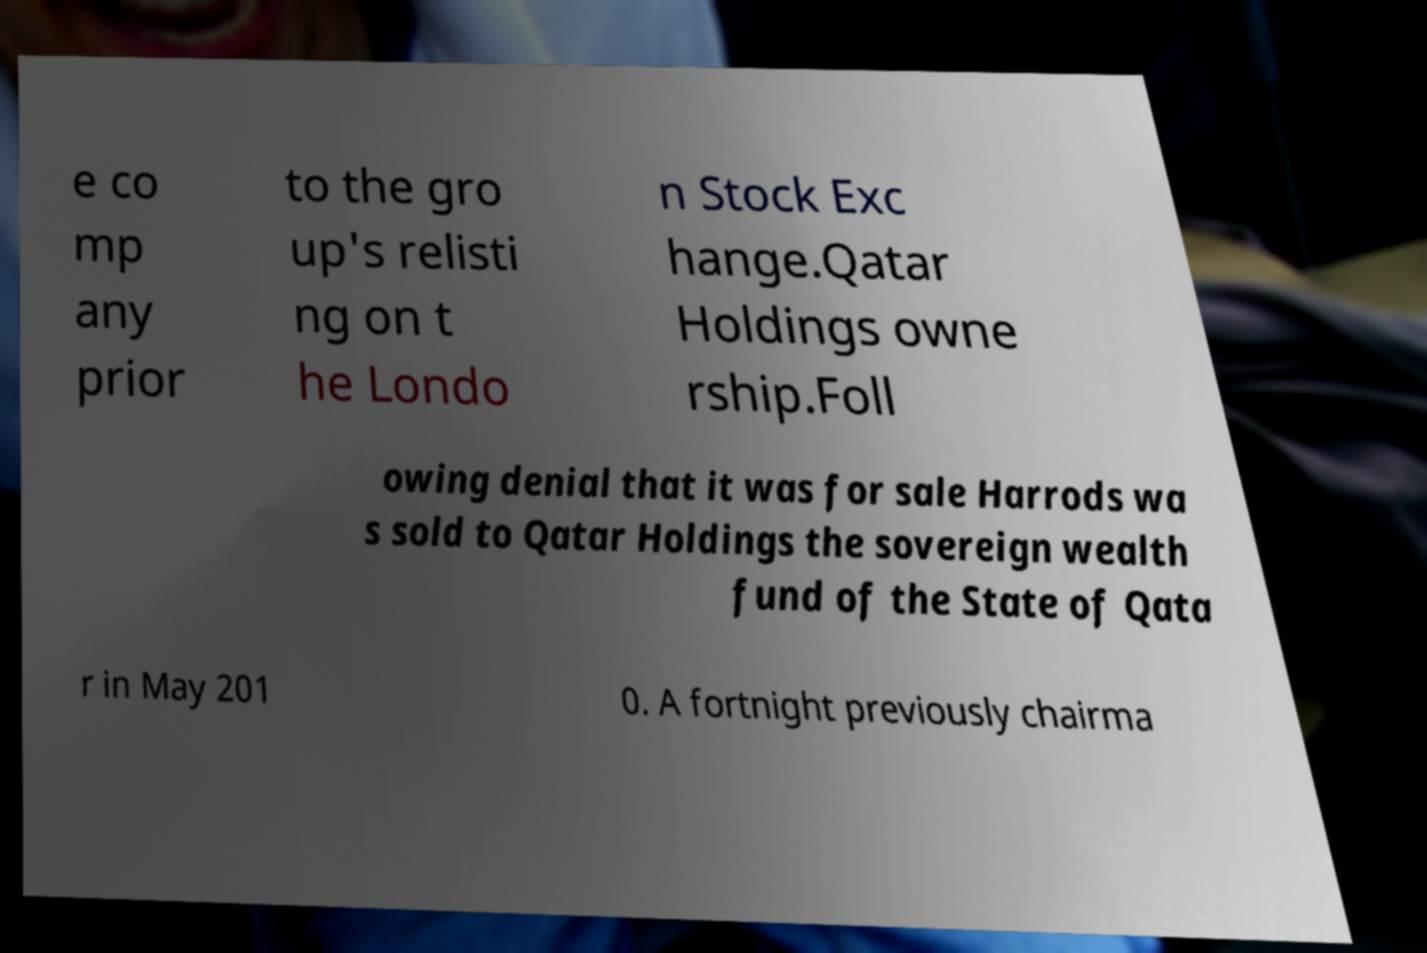What messages or text are displayed in this image? I need them in a readable, typed format. e co mp any prior to the gro up's relisti ng on t he Londo n Stock Exc hange.Qatar Holdings owne rship.Foll owing denial that it was for sale Harrods wa s sold to Qatar Holdings the sovereign wealth fund of the State of Qata r in May 201 0. A fortnight previously chairma 